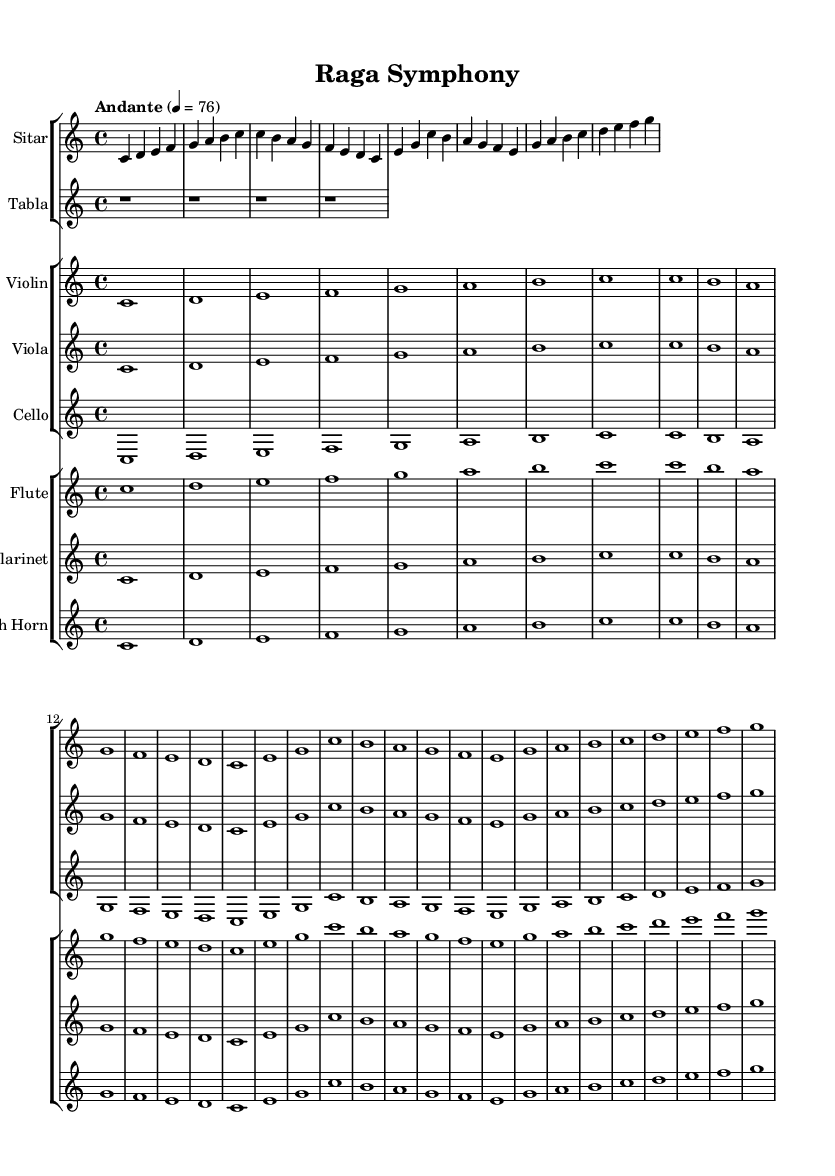What is the key signature of this music? The key signature is indicated at the beginning of the score, which shows no sharps or flats, indicating C major.
Answer: C major What is the time signature of this music? The time signature is found at the start of the score, showing 4/4, which means there are four beats per measure.
Answer: 4/4 What is the tempo marking for this music? The tempo is expressed at the beginning and indicates "Andante" with a metronome marking of 76 beats per minute.
Answer: Andante, 76 Which instruments are featured in the first group of the score? The first group contains the Sitar and Tabla as indicated by the staff names.
Answer: Sitar, Tabla How many measures are present in the Sitar part? The Sitar part has four measures, as counted from the musical notation.
Answer: 4 What is the relationship between the Sitar and the Violin parts in terms of melodic range? Both the Sitar and Violin parts are in similar ranges, contributing to a harmonious blend, but the Sitar typically plays at a slightly higher pitch.
Answer: Similar ranges What musical elements indicate a fusion between Indian classical and Western symphonic styles in this piece? The presence of traditional Indian instruments like Sitar and Tabla alongside Western orchestral strings and woodwinds highlights the fusion of styles.
Answer: Traditional Indian and Western orchestral elements 